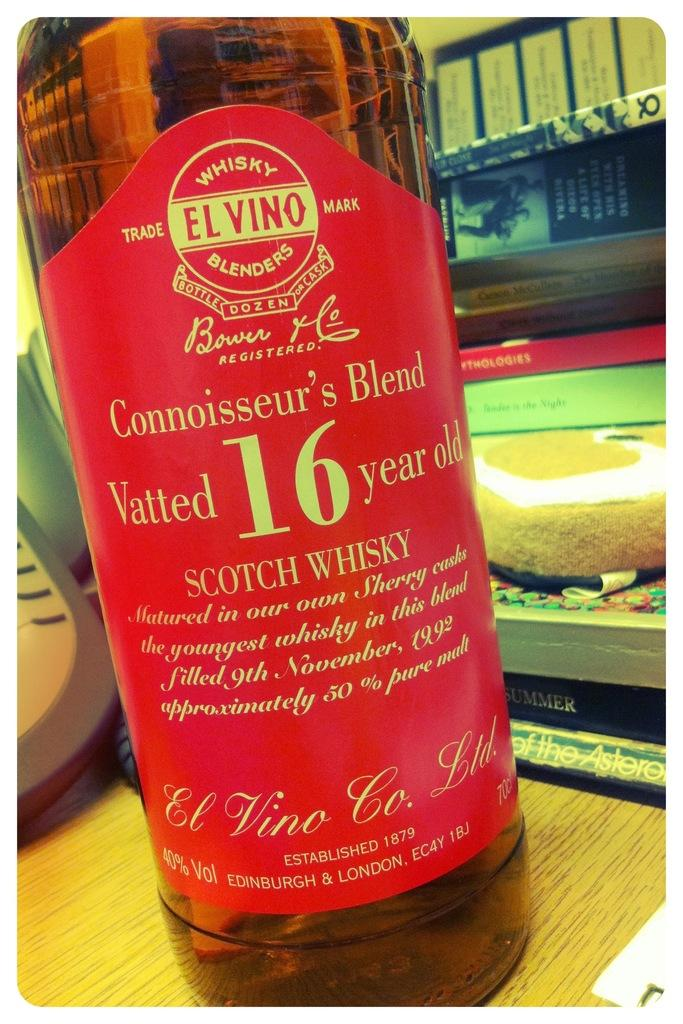<image>
Offer a succinct explanation of the picture presented. A bottle of 16 year old Scotch whisky sits on a wooden table. 